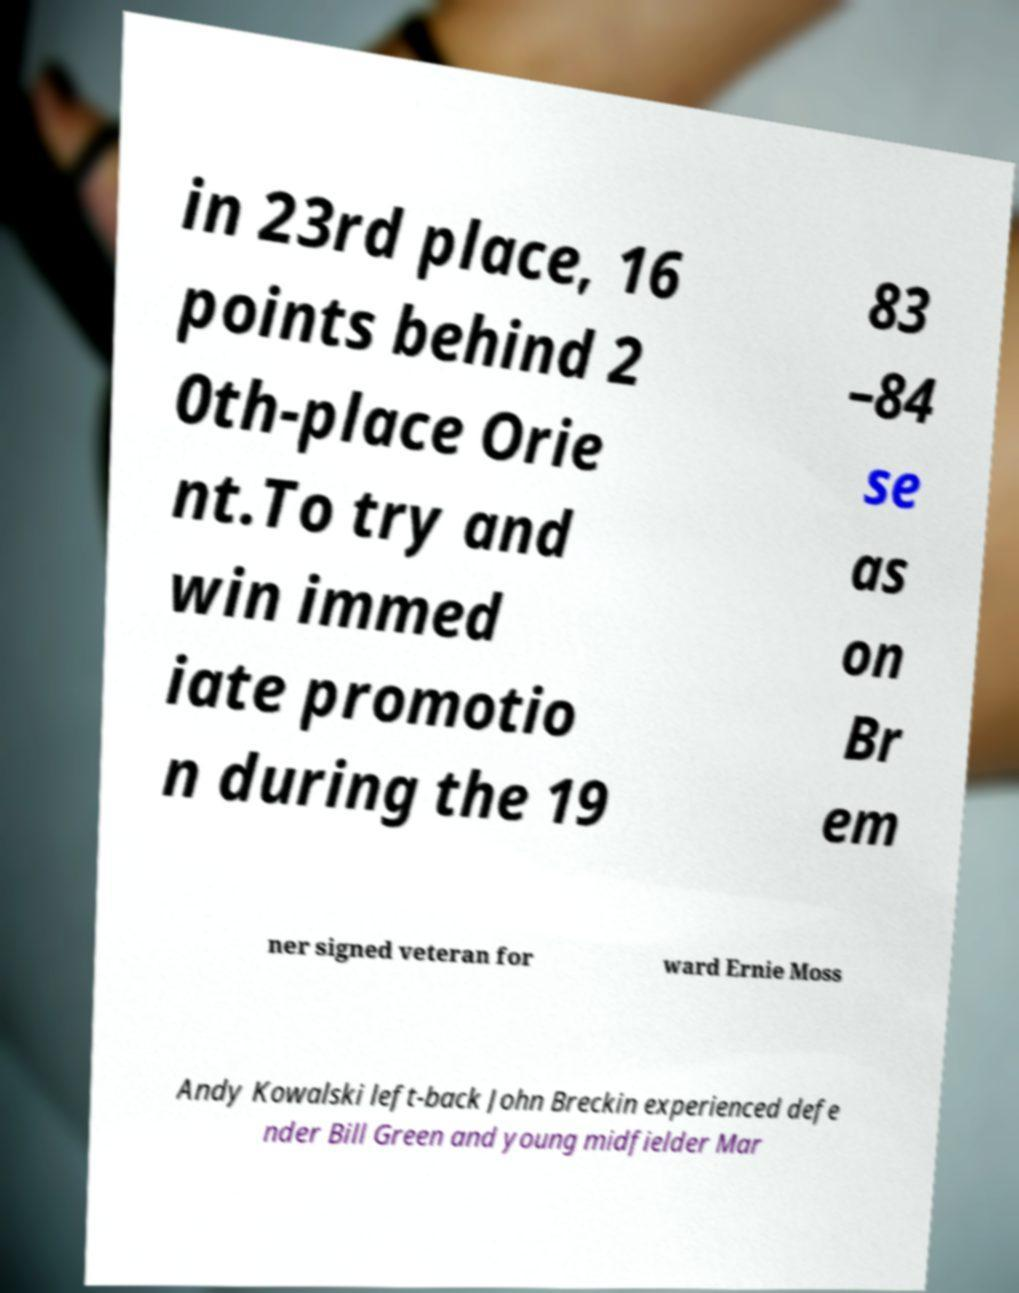For documentation purposes, I need the text within this image transcribed. Could you provide that? in 23rd place, 16 points behind 2 0th-place Orie nt.To try and win immed iate promotio n during the 19 83 –84 se as on Br em ner signed veteran for ward Ernie Moss Andy Kowalski left-back John Breckin experienced defe nder Bill Green and young midfielder Mar 